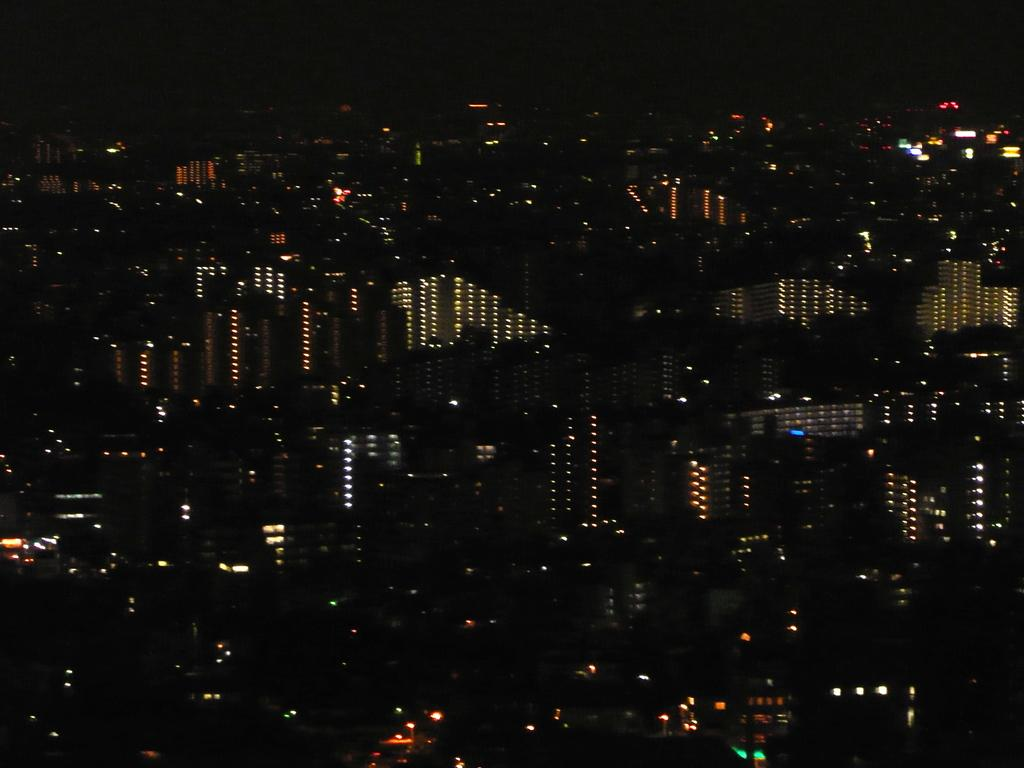What types of structures are located at the bottom of the image? There are buildings and houses at the bottom of the image. What can be seen illuminated in the image? Lights are visible in the image. What shape is the goldfish swimming in the image? There is no goldfish present in the image. What type of work is being done in the image? The image does not depict any specific work or activity. 